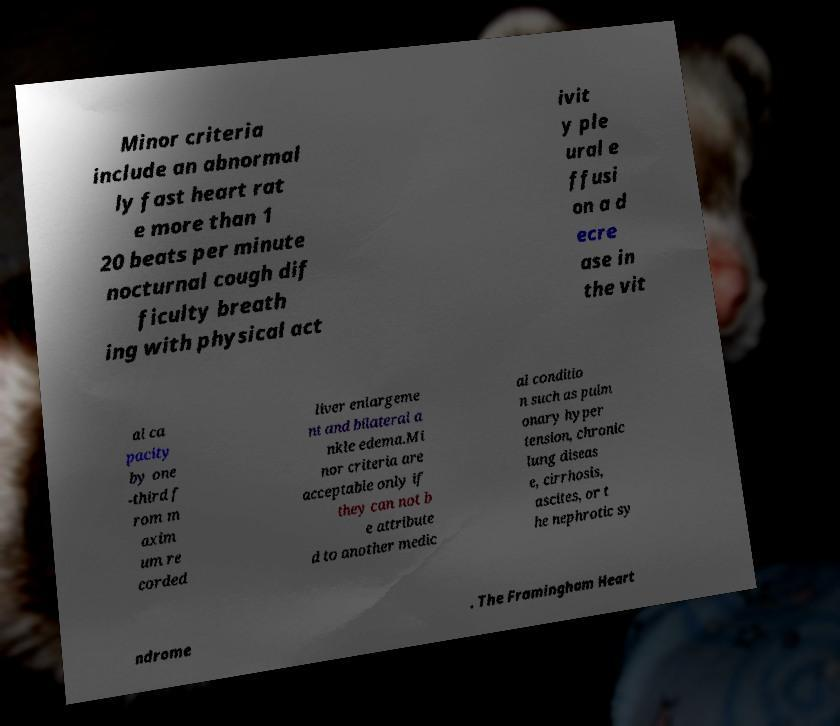For documentation purposes, I need the text within this image transcribed. Could you provide that? Minor criteria include an abnormal ly fast heart rat e more than 1 20 beats per minute nocturnal cough dif ficulty breath ing with physical act ivit y ple ural e ffusi on a d ecre ase in the vit al ca pacity by one -third f rom m axim um re corded liver enlargeme nt and bilateral a nkle edema.Mi nor criteria are acceptable only if they can not b e attribute d to another medic al conditio n such as pulm onary hyper tension, chronic lung diseas e, cirrhosis, ascites, or t he nephrotic sy ndrome . The Framingham Heart 